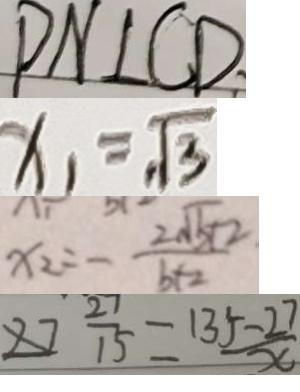<formula> <loc_0><loc_0><loc_500><loc_500>P N \bot C D 
 x _ { 1 } = \sqrt { 3 } 
 x _ { 2 } = - \frac { 2 \sqrt { 5 } + 2 } { b + 2 } 
 2 7 \frac { 2 7 } { 1 5 } = \frac { 1 3 5 - 2 7 } { x }</formula> 